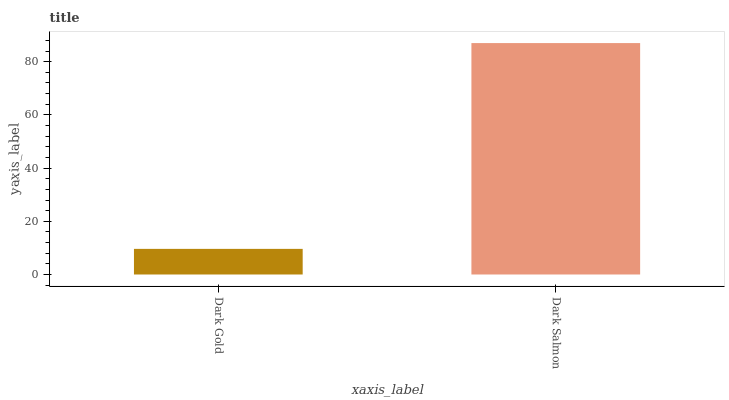Is Dark Gold the minimum?
Answer yes or no. Yes. Is Dark Salmon the maximum?
Answer yes or no. Yes. Is Dark Salmon the minimum?
Answer yes or no. No. Is Dark Salmon greater than Dark Gold?
Answer yes or no. Yes. Is Dark Gold less than Dark Salmon?
Answer yes or no. Yes. Is Dark Gold greater than Dark Salmon?
Answer yes or no. No. Is Dark Salmon less than Dark Gold?
Answer yes or no. No. Is Dark Salmon the high median?
Answer yes or no. Yes. Is Dark Gold the low median?
Answer yes or no. Yes. Is Dark Gold the high median?
Answer yes or no. No. Is Dark Salmon the low median?
Answer yes or no. No. 